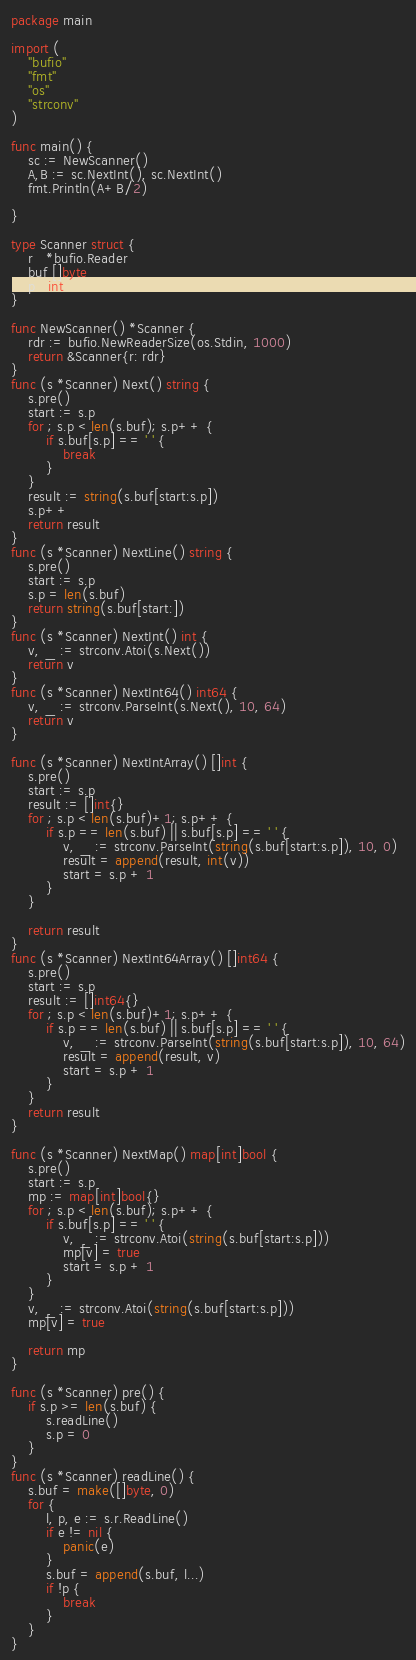<code> <loc_0><loc_0><loc_500><loc_500><_Go_>package main

import (
	"bufio"
	"fmt"
	"os"
	"strconv"
)

func main() {
	sc := NewScanner()
	A,B := sc.NextInt(), sc.NextInt()
	fmt.Println(A+B/2)

}

type Scanner struct {
	r   *bufio.Reader
	buf []byte
	p   int
}

func NewScanner() *Scanner {
	rdr := bufio.NewReaderSize(os.Stdin, 1000)
	return &Scanner{r: rdr}
}
func (s *Scanner) Next() string {
	s.pre()
	start := s.p
	for ; s.p < len(s.buf); s.p++ {
		if s.buf[s.p] == ' ' {
			break
		}
	}
	result := string(s.buf[start:s.p])
	s.p++
	return result
}
func (s *Scanner) NextLine() string {
	s.pre()
	start := s.p
	s.p = len(s.buf)
	return string(s.buf[start:])
}
func (s *Scanner) NextInt() int {
	v, _ := strconv.Atoi(s.Next())
	return v
}
func (s *Scanner) NextInt64() int64 {
	v, _ := strconv.ParseInt(s.Next(), 10, 64)
	return v
}

func (s *Scanner) NextIntArray() []int {
	s.pre()
	start := s.p
	result := []int{}
	for ; s.p < len(s.buf)+1; s.p++ {
		if s.p == len(s.buf) || s.buf[s.p] == ' ' {
			v, _ := strconv.ParseInt(string(s.buf[start:s.p]), 10, 0)
			result = append(result, int(v))
			start = s.p + 1
		}
	}

	return result
}
func (s *Scanner) NextInt64Array() []int64 {
	s.pre()
	start := s.p
	result := []int64{}
	for ; s.p < len(s.buf)+1; s.p++ {
		if s.p == len(s.buf) || s.buf[s.p] == ' ' {
			v, _ := strconv.ParseInt(string(s.buf[start:s.p]), 10, 64)
			result = append(result, v)
			start = s.p + 1
		}
	}
	return result
}

func (s *Scanner) NextMap() map[int]bool {
	s.pre()
	start := s.p
	mp := map[int]bool{}
	for ; s.p < len(s.buf); s.p++ {
		if s.buf[s.p] == ' ' {
			v, _ := strconv.Atoi(string(s.buf[start:s.p]))
			mp[v] = true
			start = s.p + 1
		}
	}
	v, _ := strconv.Atoi(string(s.buf[start:s.p]))
	mp[v] = true

	return mp
}

func (s *Scanner) pre() {
	if s.p >= len(s.buf) {
		s.readLine()
		s.p = 0
	}
}
func (s *Scanner) readLine() {
	s.buf = make([]byte, 0)
	for {
		l, p, e := s.r.ReadLine()
		if e != nil {
			panic(e)
		}
		s.buf = append(s.buf, l...)
		if !p {
			break
		}
	}
}
</code> 